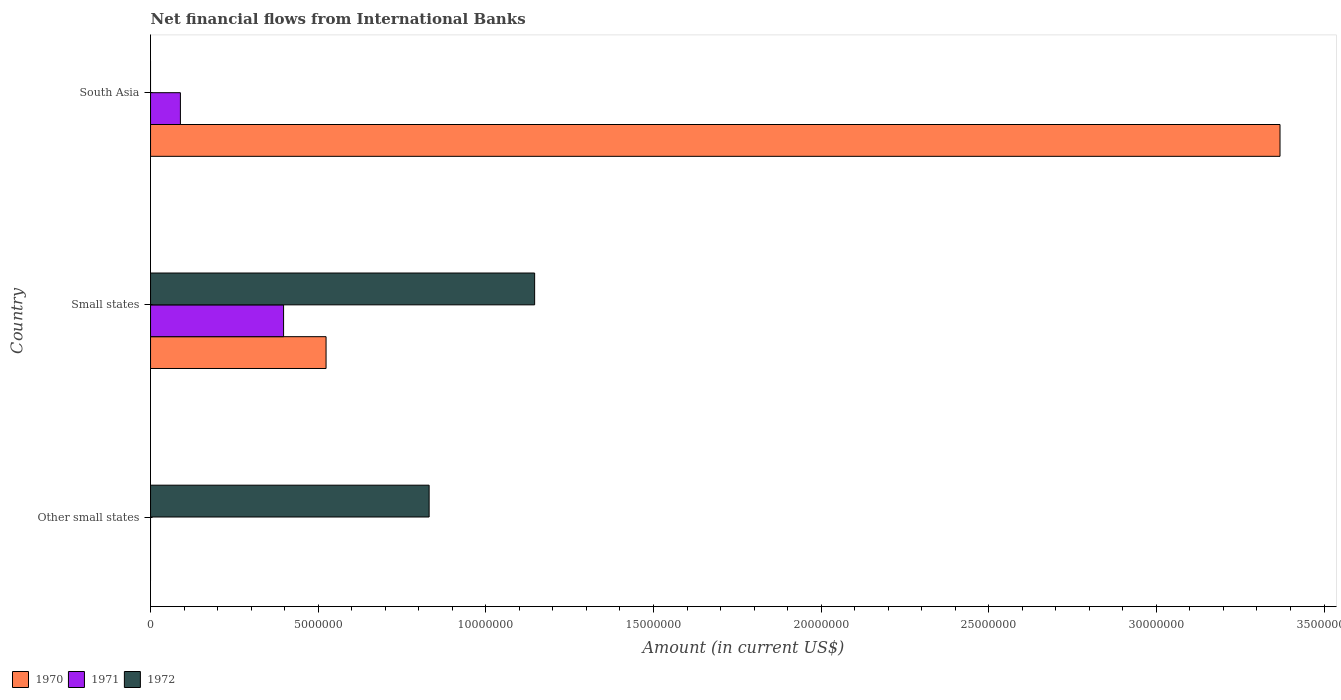How many different coloured bars are there?
Your answer should be very brief. 3. Are the number of bars per tick equal to the number of legend labels?
Ensure brevity in your answer.  No. How many bars are there on the 1st tick from the bottom?
Offer a very short reply. 1. What is the label of the 1st group of bars from the top?
Ensure brevity in your answer.  South Asia. What is the net financial aid flows in 1970 in Other small states?
Ensure brevity in your answer.  0. Across all countries, what is the maximum net financial aid flows in 1970?
Ensure brevity in your answer.  3.37e+07. In which country was the net financial aid flows in 1972 maximum?
Your response must be concise. Small states. What is the total net financial aid flows in 1972 in the graph?
Keep it short and to the point. 1.98e+07. What is the difference between the net financial aid flows in 1972 in Other small states and that in Small states?
Provide a short and direct response. -3.15e+06. What is the difference between the net financial aid flows in 1970 in South Asia and the net financial aid flows in 1972 in Small states?
Give a very brief answer. 2.22e+07. What is the average net financial aid flows in 1972 per country?
Your response must be concise. 6.59e+06. What is the difference between the net financial aid flows in 1972 and net financial aid flows in 1970 in Small states?
Make the answer very short. 6.22e+06. What is the ratio of the net financial aid flows in 1972 in Other small states to that in Small states?
Make the answer very short. 0.73. Is the net financial aid flows in 1971 in Small states less than that in South Asia?
Your response must be concise. No. What is the difference between the highest and the lowest net financial aid flows in 1972?
Make the answer very short. 1.15e+07. How many bars are there?
Ensure brevity in your answer.  6. How many countries are there in the graph?
Provide a short and direct response. 3. Are the values on the major ticks of X-axis written in scientific E-notation?
Offer a very short reply. No. Does the graph contain any zero values?
Your answer should be compact. Yes. Does the graph contain grids?
Provide a succinct answer. No. Where does the legend appear in the graph?
Offer a terse response. Bottom left. How many legend labels are there?
Your response must be concise. 3. How are the legend labels stacked?
Your response must be concise. Horizontal. What is the title of the graph?
Offer a terse response. Net financial flows from International Banks. What is the label or title of the X-axis?
Offer a very short reply. Amount (in current US$). What is the Amount (in current US$) in 1970 in Other small states?
Your answer should be very brief. 0. What is the Amount (in current US$) of 1972 in Other small states?
Provide a succinct answer. 8.31e+06. What is the Amount (in current US$) of 1970 in Small states?
Ensure brevity in your answer.  5.24e+06. What is the Amount (in current US$) in 1971 in Small states?
Keep it short and to the point. 3.97e+06. What is the Amount (in current US$) of 1972 in Small states?
Your response must be concise. 1.15e+07. What is the Amount (in current US$) in 1970 in South Asia?
Ensure brevity in your answer.  3.37e+07. What is the Amount (in current US$) in 1971 in South Asia?
Offer a very short reply. 8.91e+05. Across all countries, what is the maximum Amount (in current US$) in 1970?
Provide a short and direct response. 3.37e+07. Across all countries, what is the maximum Amount (in current US$) in 1971?
Keep it short and to the point. 3.97e+06. Across all countries, what is the maximum Amount (in current US$) in 1972?
Make the answer very short. 1.15e+07. Across all countries, what is the minimum Amount (in current US$) of 1970?
Your response must be concise. 0. Across all countries, what is the minimum Amount (in current US$) in 1971?
Give a very brief answer. 0. Across all countries, what is the minimum Amount (in current US$) in 1972?
Keep it short and to the point. 0. What is the total Amount (in current US$) of 1970 in the graph?
Provide a succinct answer. 3.89e+07. What is the total Amount (in current US$) of 1971 in the graph?
Ensure brevity in your answer.  4.86e+06. What is the total Amount (in current US$) of 1972 in the graph?
Your response must be concise. 1.98e+07. What is the difference between the Amount (in current US$) in 1972 in Other small states and that in Small states?
Offer a terse response. -3.15e+06. What is the difference between the Amount (in current US$) in 1970 in Small states and that in South Asia?
Give a very brief answer. -2.85e+07. What is the difference between the Amount (in current US$) in 1971 in Small states and that in South Asia?
Make the answer very short. 3.08e+06. What is the difference between the Amount (in current US$) of 1970 in Small states and the Amount (in current US$) of 1971 in South Asia?
Ensure brevity in your answer.  4.34e+06. What is the average Amount (in current US$) of 1970 per country?
Keep it short and to the point. 1.30e+07. What is the average Amount (in current US$) in 1971 per country?
Your answer should be compact. 1.62e+06. What is the average Amount (in current US$) in 1972 per country?
Give a very brief answer. 6.59e+06. What is the difference between the Amount (in current US$) in 1970 and Amount (in current US$) in 1971 in Small states?
Give a very brief answer. 1.27e+06. What is the difference between the Amount (in current US$) of 1970 and Amount (in current US$) of 1972 in Small states?
Provide a succinct answer. -6.22e+06. What is the difference between the Amount (in current US$) of 1971 and Amount (in current US$) of 1972 in Small states?
Give a very brief answer. -7.49e+06. What is the difference between the Amount (in current US$) in 1970 and Amount (in current US$) in 1971 in South Asia?
Your answer should be compact. 3.28e+07. What is the ratio of the Amount (in current US$) of 1972 in Other small states to that in Small states?
Provide a short and direct response. 0.73. What is the ratio of the Amount (in current US$) of 1970 in Small states to that in South Asia?
Provide a short and direct response. 0.16. What is the ratio of the Amount (in current US$) of 1971 in Small states to that in South Asia?
Offer a terse response. 4.45. What is the difference between the highest and the lowest Amount (in current US$) in 1970?
Provide a short and direct response. 3.37e+07. What is the difference between the highest and the lowest Amount (in current US$) in 1971?
Offer a terse response. 3.97e+06. What is the difference between the highest and the lowest Amount (in current US$) in 1972?
Your answer should be very brief. 1.15e+07. 